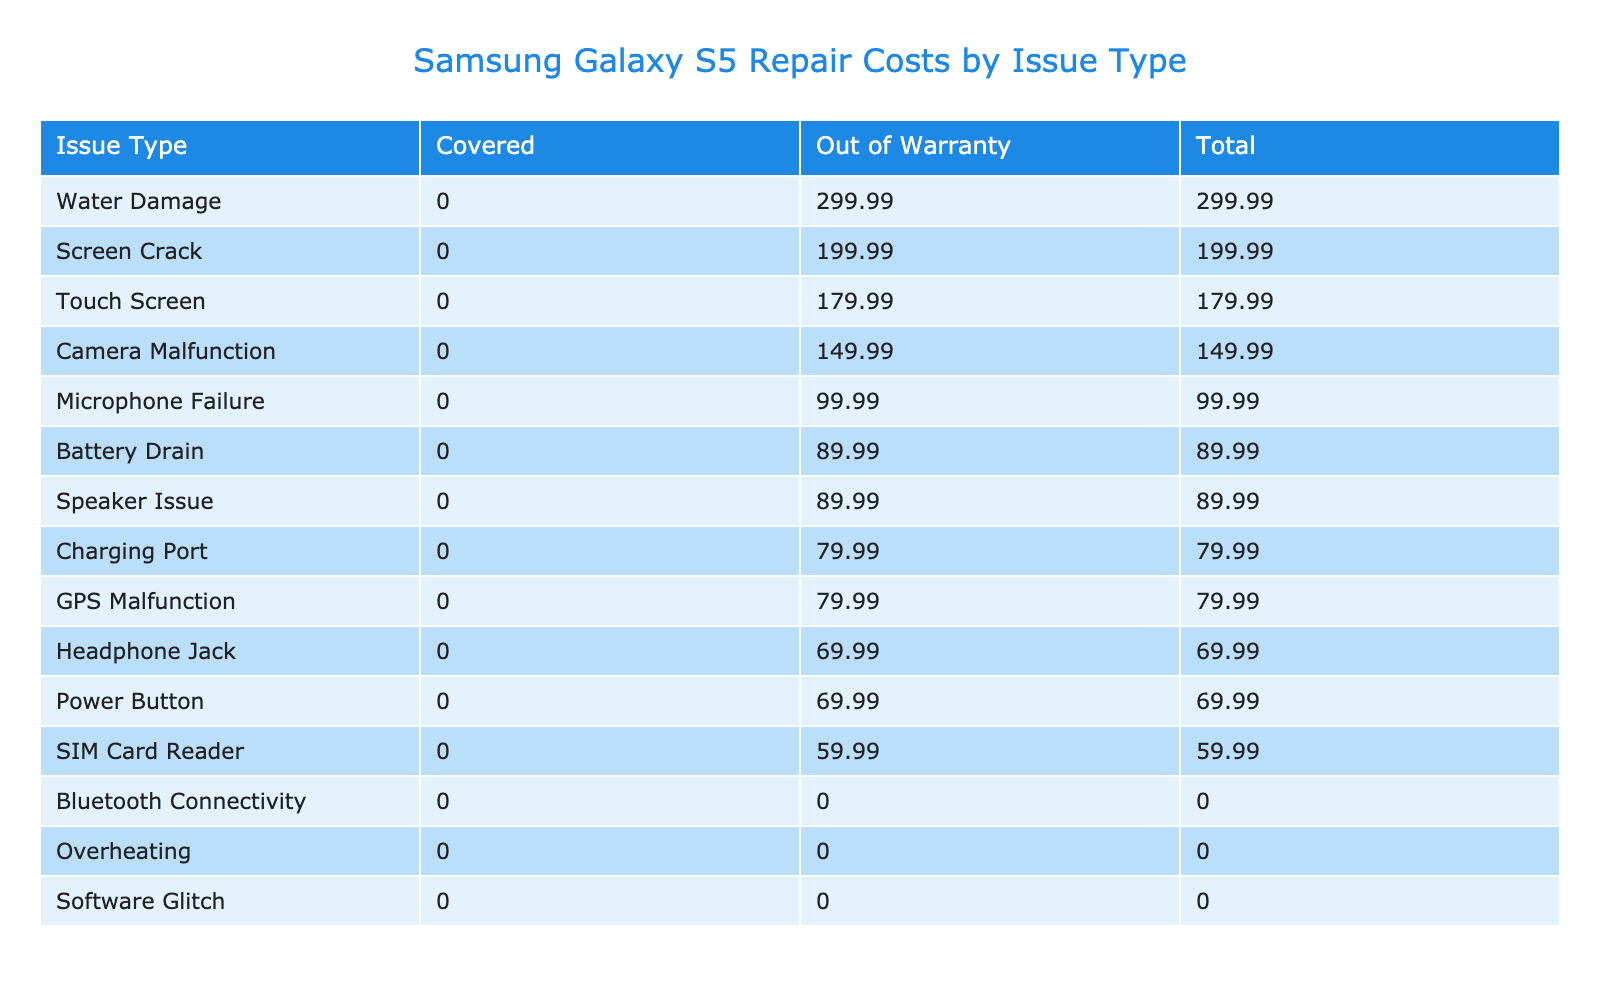What is the total repair cost for screen crack issues? The table shows that for the issue type "Screen Crack," the repair cost under "Out of Warranty" is 199.99. As there's no cost associated with warranty coverage for this issue type, the total cost remains 199.99.
Answer: 199.99 Which issue type has the highest total repair cost? By looking at the "Total" column, the issue type "Water Damage" has the highest total repair cost, which is 299.99.
Answer: Water Damage Is the charging port issue covered under warranty? From the table, the charging port issue falls under the "Out of Warranty" category. Therefore, it is not covered by warranty.
Answer: No What is the average repair cost for issues that are out of warranty? To find the average for "Out of Warranty," sum the costs: 199.99 + 89.99 + 299.99 + 149.99 + 79.99 + 69.99 + 89.99 + 179.99 + 99.99 + 59.99 + 79.99 + 69.99 = 1090.88. There are 12 entries, so the average is 1090.88 / 12 = 90.91.
Answer: 90.91 How many issue types are covered under warranty? The "Covered" column lists three issue types: Software Glitch, Overheating, and Bluetooth Connectivity. Thus, there are three types that are covered under warranty.
Answer: 3 